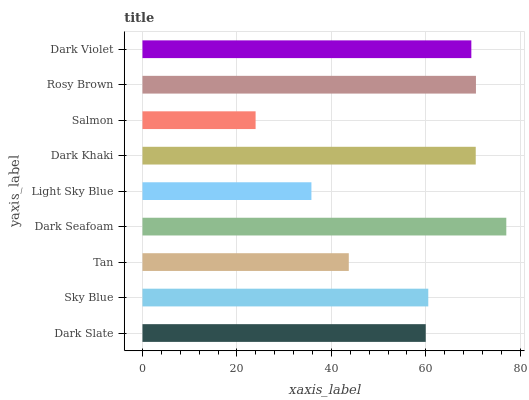Is Salmon the minimum?
Answer yes or no. Yes. Is Dark Seafoam the maximum?
Answer yes or no. Yes. Is Sky Blue the minimum?
Answer yes or no. No. Is Sky Blue the maximum?
Answer yes or no. No. Is Sky Blue greater than Dark Slate?
Answer yes or no. Yes. Is Dark Slate less than Sky Blue?
Answer yes or no. Yes. Is Dark Slate greater than Sky Blue?
Answer yes or no. No. Is Sky Blue less than Dark Slate?
Answer yes or no. No. Is Sky Blue the high median?
Answer yes or no. Yes. Is Sky Blue the low median?
Answer yes or no. Yes. Is Salmon the high median?
Answer yes or no. No. Is Tan the low median?
Answer yes or no. No. 